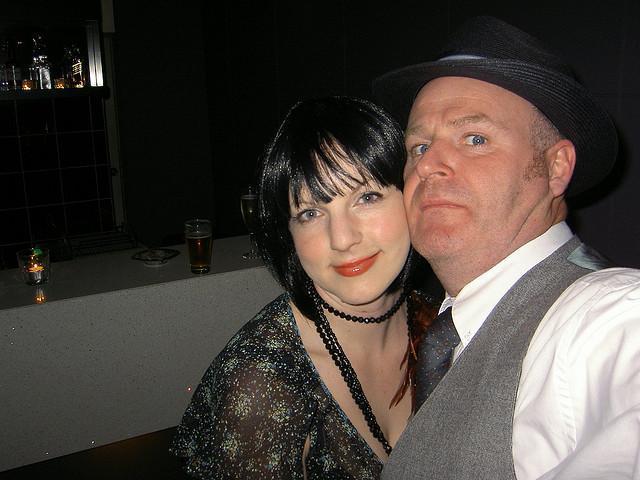How many people are wearing a tie?
Give a very brief answer. 1. How many people are there?
Give a very brief answer. 2. How many orange cups are there?
Give a very brief answer. 0. 